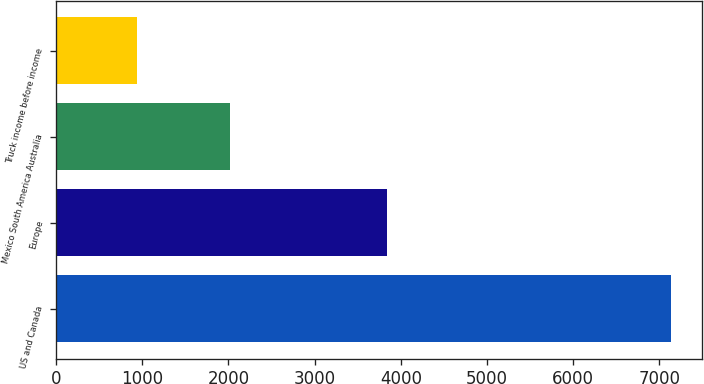<chart> <loc_0><loc_0><loc_500><loc_500><bar_chart><fcel>US and Canada<fcel>Europe<fcel>Mexico South America Australia<fcel>Truck income before income<nl><fcel>7138.1<fcel>3844.4<fcel>2020.4<fcel>936.7<nl></chart> 